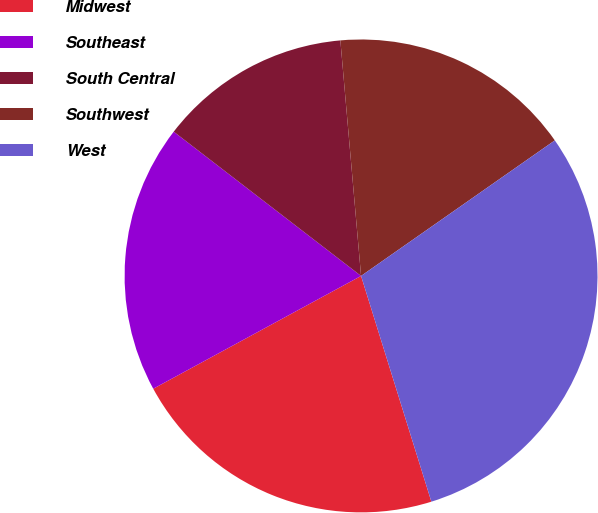<chart> <loc_0><loc_0><loc_500><loc_500><pie_chart><fcel>Midwest<fcel>Southeast<fcel>South Central<fcel>Southwest<fcel>West<nl><fcel>21.89%<fcel>18.36%<fcel>13.16%<fcel>16.68%<fcel>29.91%<nl></chart> 